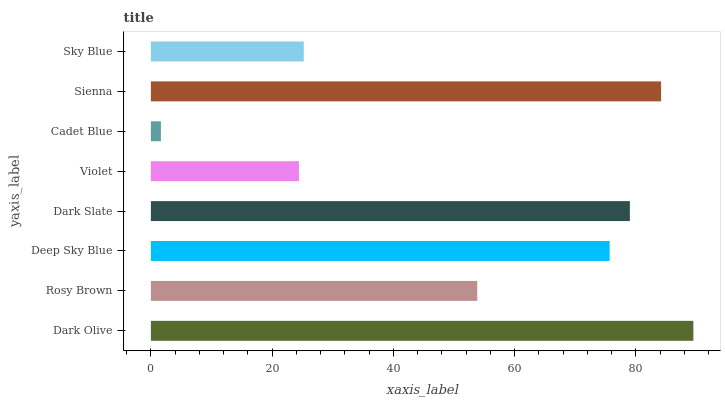Is Cadet Blue the minimum?
Answer yes or no. Yes. Is Dark Olive the maximum?
Answer yes or no. Yes. Is Rosy Brown the minimum?
Answer yes or no. No. Is Rosy Brown the maximum?
Answer yes or no. No. Is Dark Olive greater than Rosy Brown?
Answer yes or no. Yes. Is Rosy Brown less than Dark Olive?
Answer yes or no. Yes. Is Rosy Brown greater than Dark Olive?
Answer yes or no. No. Is Dark Olive less than Rosy Brown?
Answer yes or no. No. Is Deep Sky Blue the high median?
Answer yes or no. Yes. Is Rosy Brown the low median?
Answer yes or no. Yes. Is Sienna the high median?
Answer yes or no. No. Is Cadet Blue the low median?
Answer yes or no. No. 